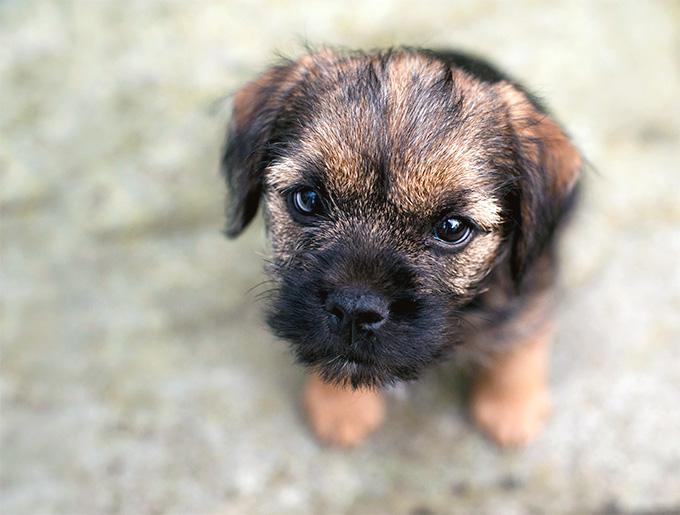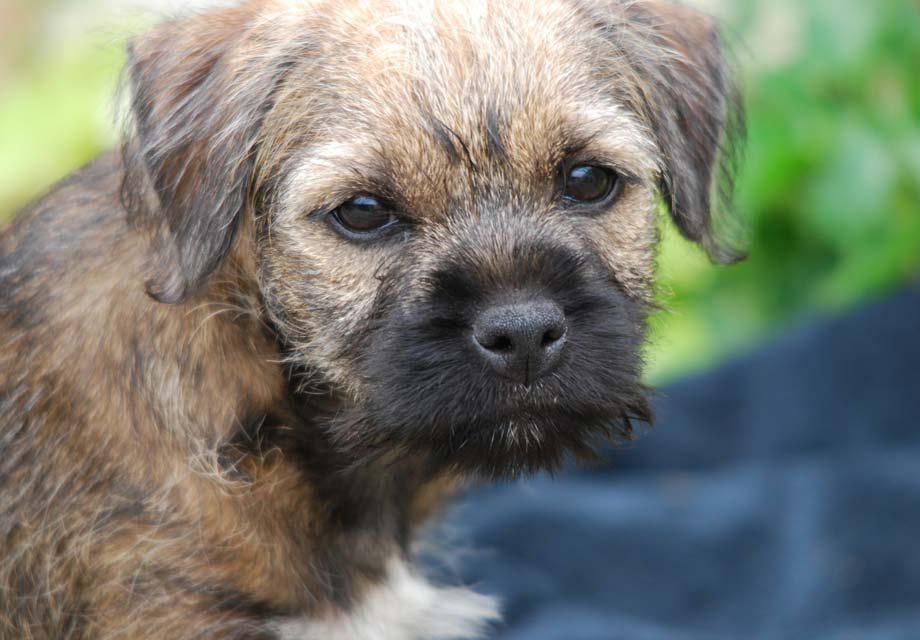The first image is the image on the left, the second image is the image on the right. Considering the images on both sides, is "At least one dog is wearing a red collar and looking forward." valid? Answer yes or no. No. 